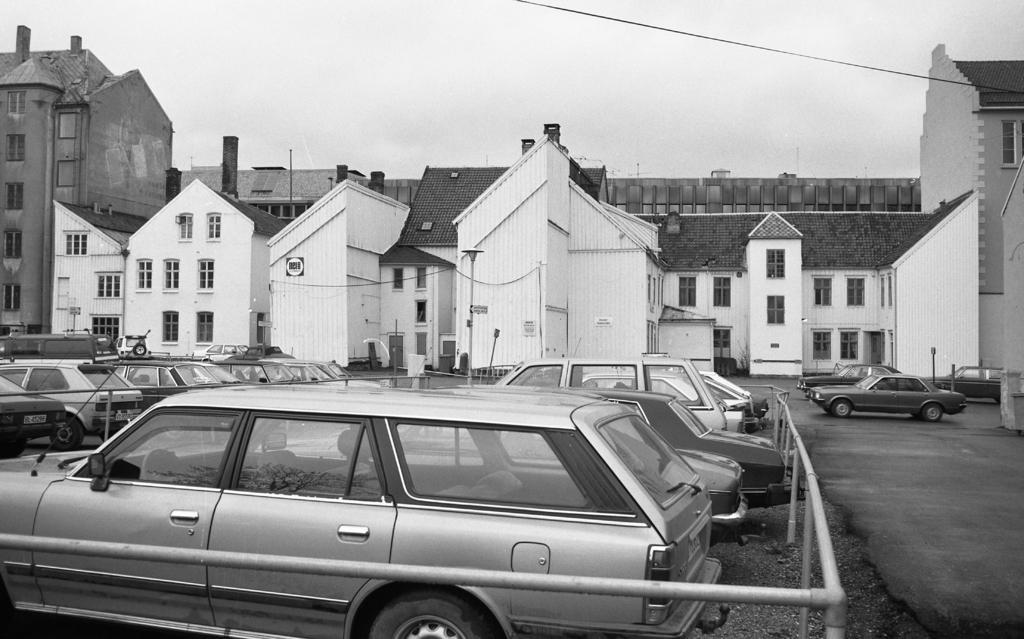Describe this image in one or two sentences. This is a black and white picture, in the there are cars inside a fence and outside on road, in the back there are buildings and above its sky. 